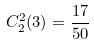<formula> <loc_0><loc_0><loc_500><loc_500>C _ { 2 } ^ { 2 } ( 3 ) = \frac { 1 7 } { 5 0 }</formula> 